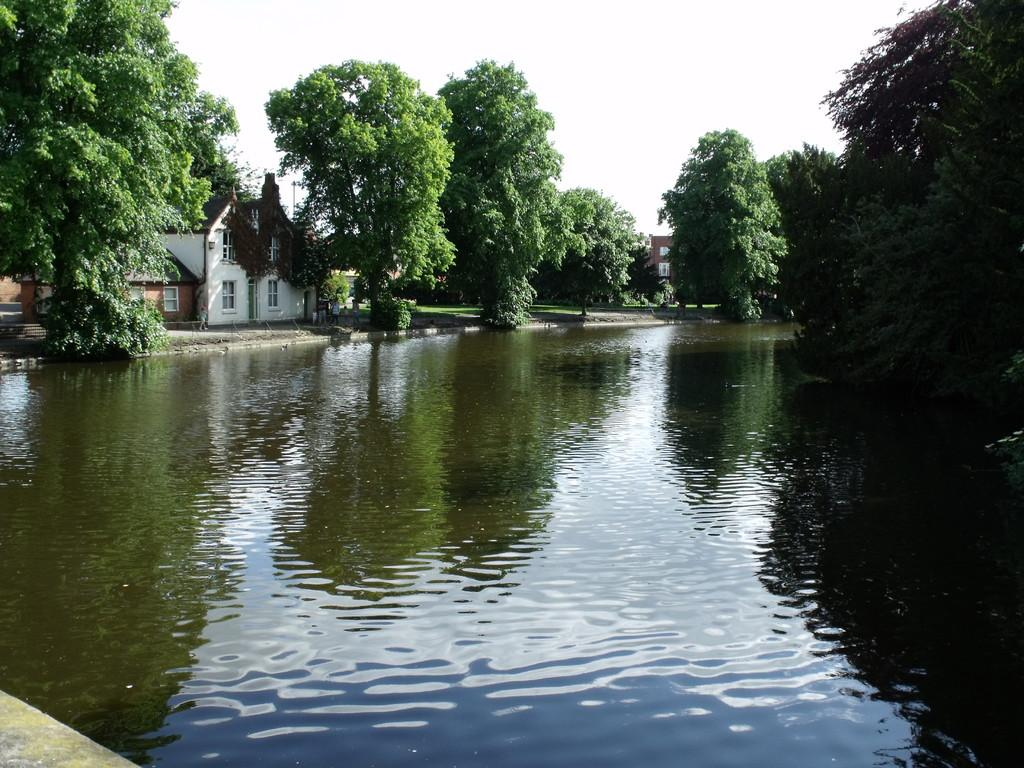What is visible in the image? Water, trees, and buildings are visible in the image. Can you describe the water in the image? The water is visible, but its specific characteristics are not mentioned in the facts. What type of vegetation can be seen in the image? Trees are present in the image. What structures are visible in the image? Buildings are visible in the image. What type of instrument is being played on the ship in the image? There is no ship or instrument present in the image. How many pizzas are visible on the trees in the image? There are no pizzas present in the image; it features water, trees, and buildings. 